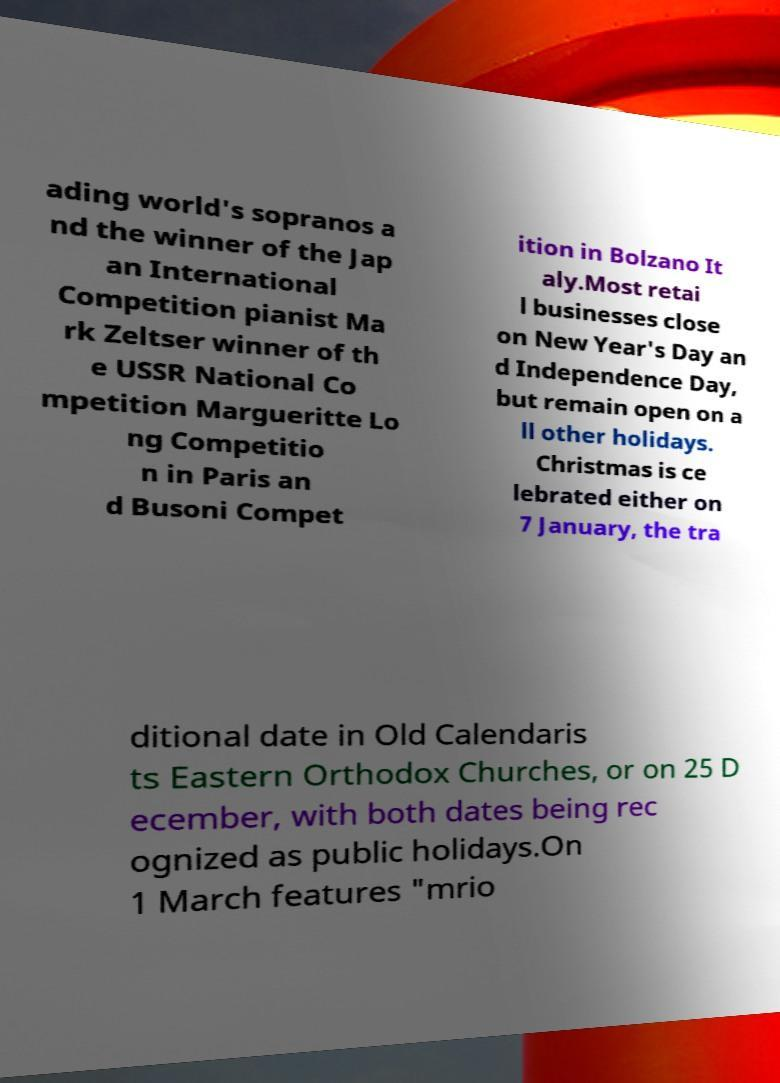What messages or text are displayed in this image? I need them in a readable, typed format. ading world's sopranos a nd the winner of the Jap an International Competition pianist Ma rk Zeltser winner of th e USSR National Co mpetition Margueritte Lo ng Competitio n in Paris an d Busoni Compet ition in Bolzano It aly.Most retai l businesses close on New Year's Day an d Independence Day, but remain open on a ll other holidays. Christmas is ce lebrated either on 7 January, the tra ditional date in Old Calendaris ts Eastern Orthodox Churches, or on 25 D ecember, with both dates being rec ognized as public holidays.On 1 March features "mrio 